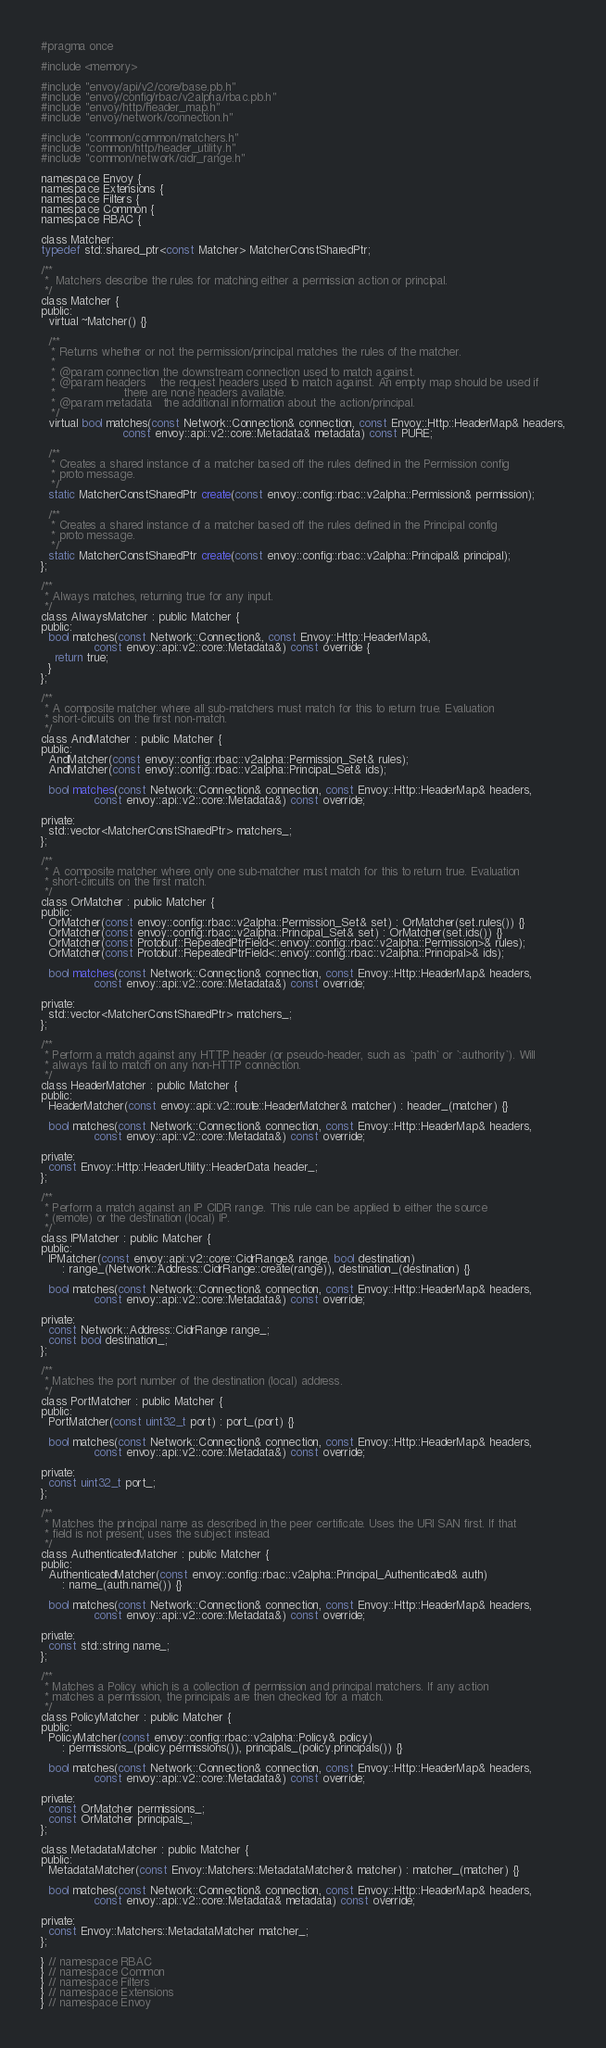Convert code to text. <code><loc_0><loc_0><loc_500><loc_500><_C_>#pragma once

#include <memory>

#include "envoy/api/v2/core/base.pb.h"
#include "envoy/config/rbac/v2alpha/rbac.pb.h"
#include "envoy/http/header_map.h"
#include "envoy/network/connection.h"

#include "common/common/matchers.h"
#include "common/http/header_utility.h"
#include "common/network/cidr_range.h"

namespace Envoy {
namespace Extensions {
namespace Filters {
namespace Common {
namespace RBAC {

class Matcher;
typedef std::shared_ptr<const Matcher> MatcherConstSharedPtr;

/**
 *  Matchers describe the rules for matching either a permission action or principal.
 */
class Matcher {
public:
  virtual ~Matcher() {}

  /**
   * Returns whether or not the permission/principal matches the rules of the matcher.
   *
   * @param connection the downstream connection used to match against.
   * @param headers    the request headers used to match against. An empty map should be used if
   *                   there are none headers available.
   * @param metadata   the additional information about the action/principal.
   */
  virtual bool matches(const Network::Connection& connection, const Envoy::Http::HeaderMap& headers,
                       const envoy::api::v2::core::Metadata& metadata) const PURE;

  /**
   * Creates a shared instance of a matcher based off the rules defined in the Permission config
   * proto message.
   */
  static MatcherConstSharedPtr create(const envoy::config::rbac::v2alpha::Permission& permission);

  /**
   * Creates a shared instance of a matcher based off the rules defined in the Principal config
   * proto message.
   */
  static MatcherConstSharedPtr create(const envoy::config::rbac::v2alpha::Principal& principal);
};

/**
 * Always matches, returning true for any input.
 */
class AlwaysMatcher : public Matcher {
public:
  bool matches(const Network::Connection&, const Envoy::Http::HeaderMap&,
               const envoy::api::v2::core::Metadata&) const override {
    return true;
  }
};

/**
 * A composite matcher where all sub-matchers must match for this to return true. Evaluation
 * short-circuits on the first non-match.
 */
class AndMatcher : public Matcher {
public:
  AndMatcher(const envoy::config::rbac::v2alpha::Permission_Set& rules);
  AndMatcher(const envoy::config::rbac::v2alpha::Principal_Set& ids);

  bool matches(const Network::Connection& connection, const Envoy::Http::HeaderMap& headers,
               const envoy::api::v2::core::Metadata&) const override;

private:
  std::vector<MatcherConstSharedPtr> matchers_;
};

/**
 * A composite matcher where only one sub-matcher must match for this to return true. Evaluation
 * short-circuits on the first match.
 */
class OrMatcher : public Matcher {
public:
  OrMatcher(const envoy::config::rbac::v2alpha::Permission_Set& set) : OrMatcher(set.rules()) {}
  OrMatcher(const envoy::config::rbac::v2alpha::Principal_Set& set) : OrMatcher(set.ids()) {}
  OrMatcher(const Protobuf::RepeatedPtrField<::envoy::config::rbac::v2alpha::Permission>& rules);
  OrMatcher(const Protobuf::RepeatedPtrField<::envoy::config::rbac::v2alpha::Principal>& ids);

  bool matches(const Network::Connection& connection, const Envoy::Http::HeaderMap& headers,
               const envoy::api::v2::core::Metadata&) const override;

private:
  std::vector<MatcherConstSharedPtr> matchers_;
};

/**
 * Perform a match against any HTTP header (or pseudo-header, such as `:path` or `:authority`). Will
 * always fail to match on any non-HTTP connection.
 */
class HeaderMatcher : public Matcher {
public:
  HeaderMatcher(const envoy::api::v2::route::HeaderMatcher& matcher) : header_(matcher) {}

  bool matches(const Network::Connection& connection, const Envoy::Http::HeaderMap& headers,
               const envoy::api::v2::core::Metadata&) const override;

private:
  const Envoy::Http::HeaderUtility::HeaderData header_;
};

/**
 * Perform a match against an IP CIDR range. This rule can be applied to either the source
 * (remote) or the destination (local) IP.
 */
class IPMatcher : public Matcher {
public:
  IPMatcher(const envoy::api::v2::core::CidrRange& range, bool destination)
      : range_(Network::Address::CidrRange::create(range)), destination_(destination) {}

  bool matches(const Network::Connection& connection, const Envoy::Http::HeaderMap& headers,
               const envoy::api::v2::core::Metadata&) const override;

private:
  const Network::Address::CidrRange range_;
  const bool destination_;
};

/**
 * Matches the port number of the destination (local) address.
 */
class PortMatcher : public Matcher {
public:
  PortMatcher(const uint32_t port) : port_(port) {}

  bool matches(const Network::Connection& connection, const Envoy::Http::HeaderMap& headers,
               const envoy::api::v2::core::Metadata&) const override;

private:
  const uint32_t port_;
};

/**
 * Matches the principal name as described in the peer certificate. Uses the URI SAN first. If that
 * field is not present, uses the subject instead.
 */
class AuthenticatedMatcher : public Matcher {
public:
  AuthenticatedMatcher(const envoy::config::rbac::v2alpha::Principal_Authenticated& auth)
      : name_(auth.name()) {}

  bool matches(const Network::Connection& connection, const Envoy::Http::HeaderMap& headers,
               const envoy::api::v2::core::Metadata&) const override;

private:
  const std::string name_;
};

/**
 * Matches a Policy which is a collection of permission and principal matchers. If any action
 * matches a permission, the principals are then checked for a match.
 */
class PolicyMatcher : public Matcher {
public:
  PolicyMatcher(const envoy::config::rbac::v2alpha::Policy& policy)
      : permissions_(policy.permissions()), principals_(policy.principals()) {}

  bool matches(const Network::Connection& connection, const Envoy::Http::HeaderMap& headers,
               const envoy::api::v2::core::Metadata&) const override;

private:
  const OrMatcher permissions_;
  const OrMatcher principals_;
};

class MetadataMatcher : public Matcher {
public:
  MetadataMatcher(const Envoy::Matchers::MetadataMatcher& matcher) : matcher_(matcher) {}

  bool matches(const Network::Connection& connection, const Envoy::Http::HeaderMap& headers,
               const envoy::api::v2::core::Metadata& metadata) const override;

private:
  const Envoy::Matchers::MetadataMatcher matcher_;
};

} // namespace RBAC
} // namespace Common
} // namespace Filters
} // namespace Extensions
} // namespace Envoy
</code> 